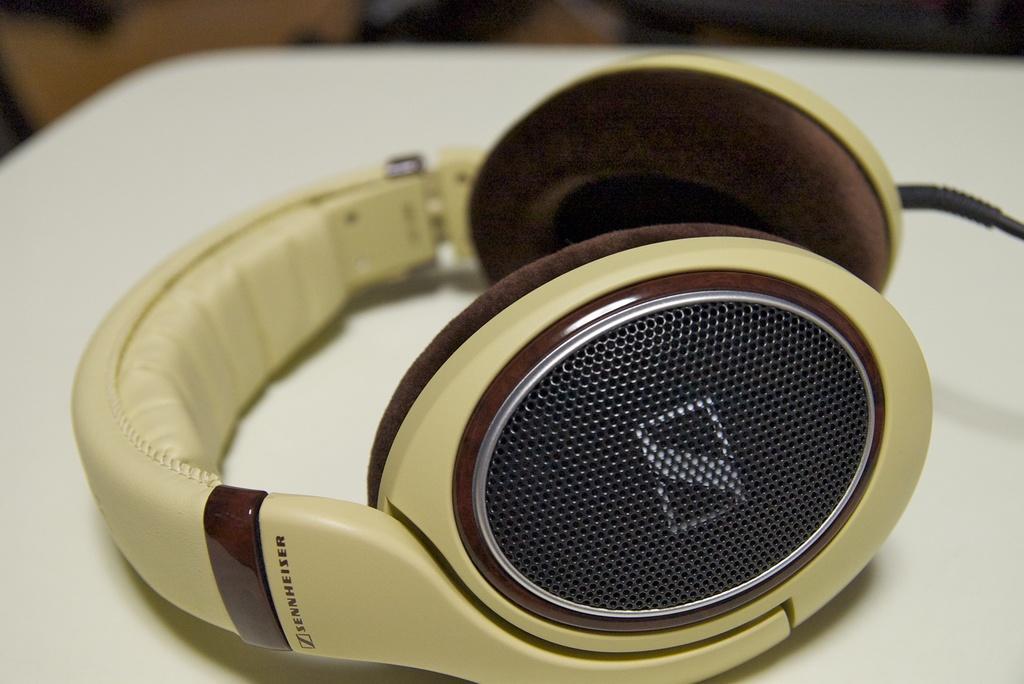In one or two sentences, can you explain what this image depicts? In the foreground I can see a headphone on the table. This image is taken may be in a room. 